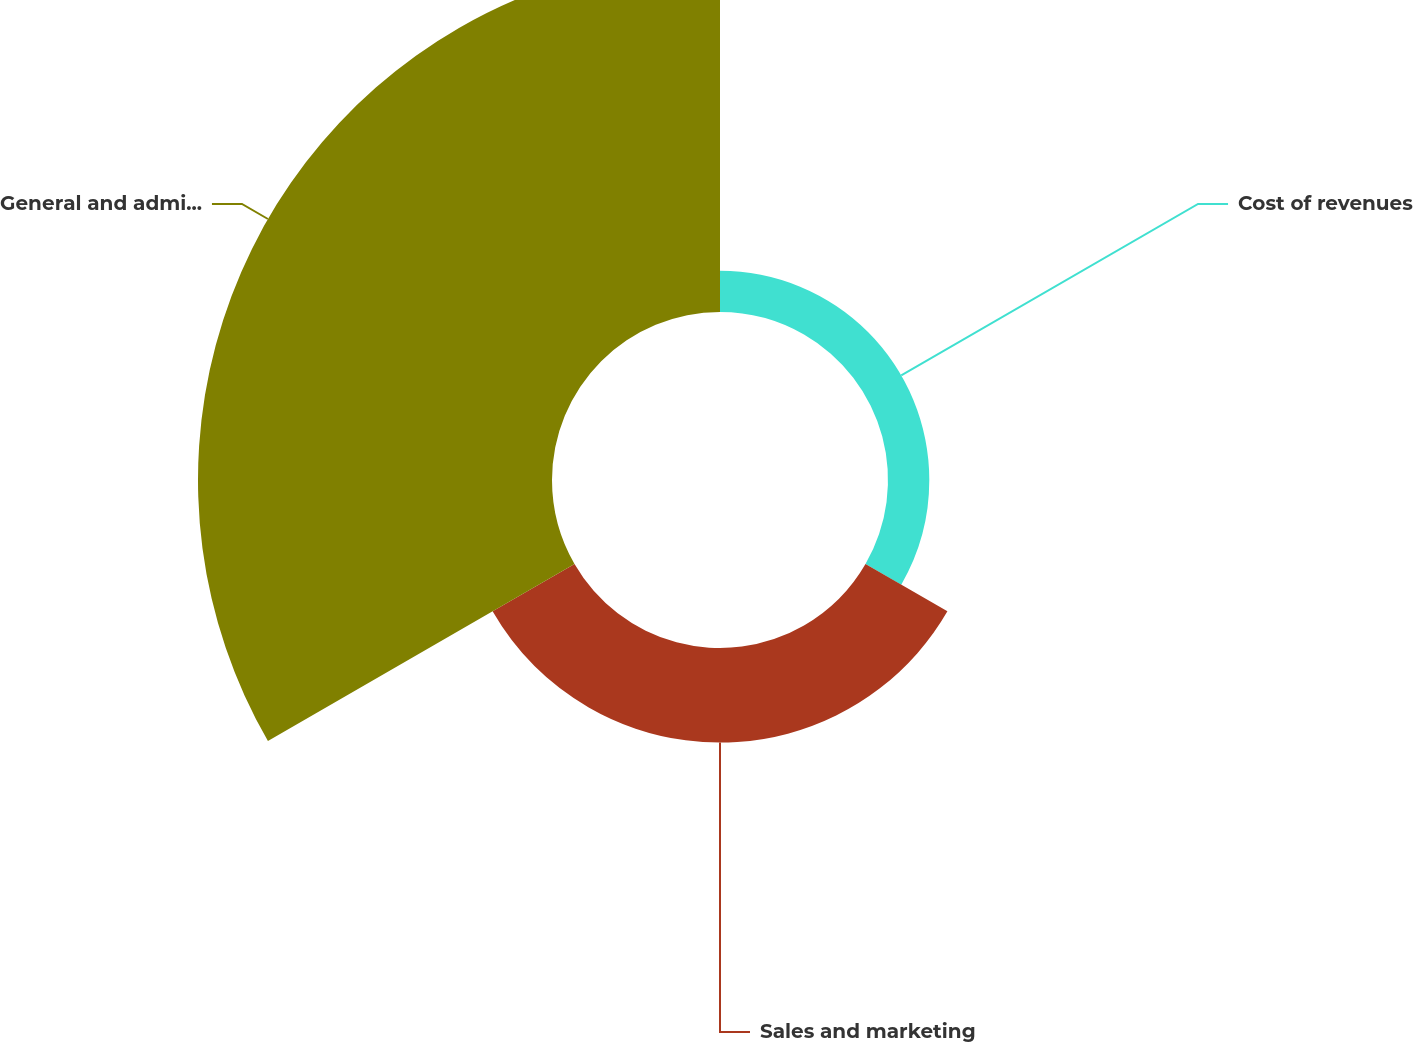Convert chart to OTSL. <chart><loc_0><loc_0><loc_500><loc_500><pie_chart><fcel>Cost of revenues<fcel>Sales and marketing<fcel>General and administrative<nl><fcel>8.43%<fcel>19.31%<fcel>72.26%<nl></chart> 